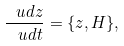<formula> <loc_0><loc_0><loc_500><loc_500>\frac { \ u d z } { \ u d t } = \{ z , H \} ,</formula> 